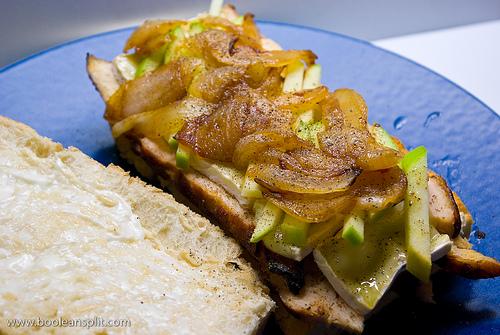What are the topping?
Write a very short answer. Onions. Is there cheese?
Answer briefly. No. What are the toppings laying on?
Write a very short answer. Bread. 